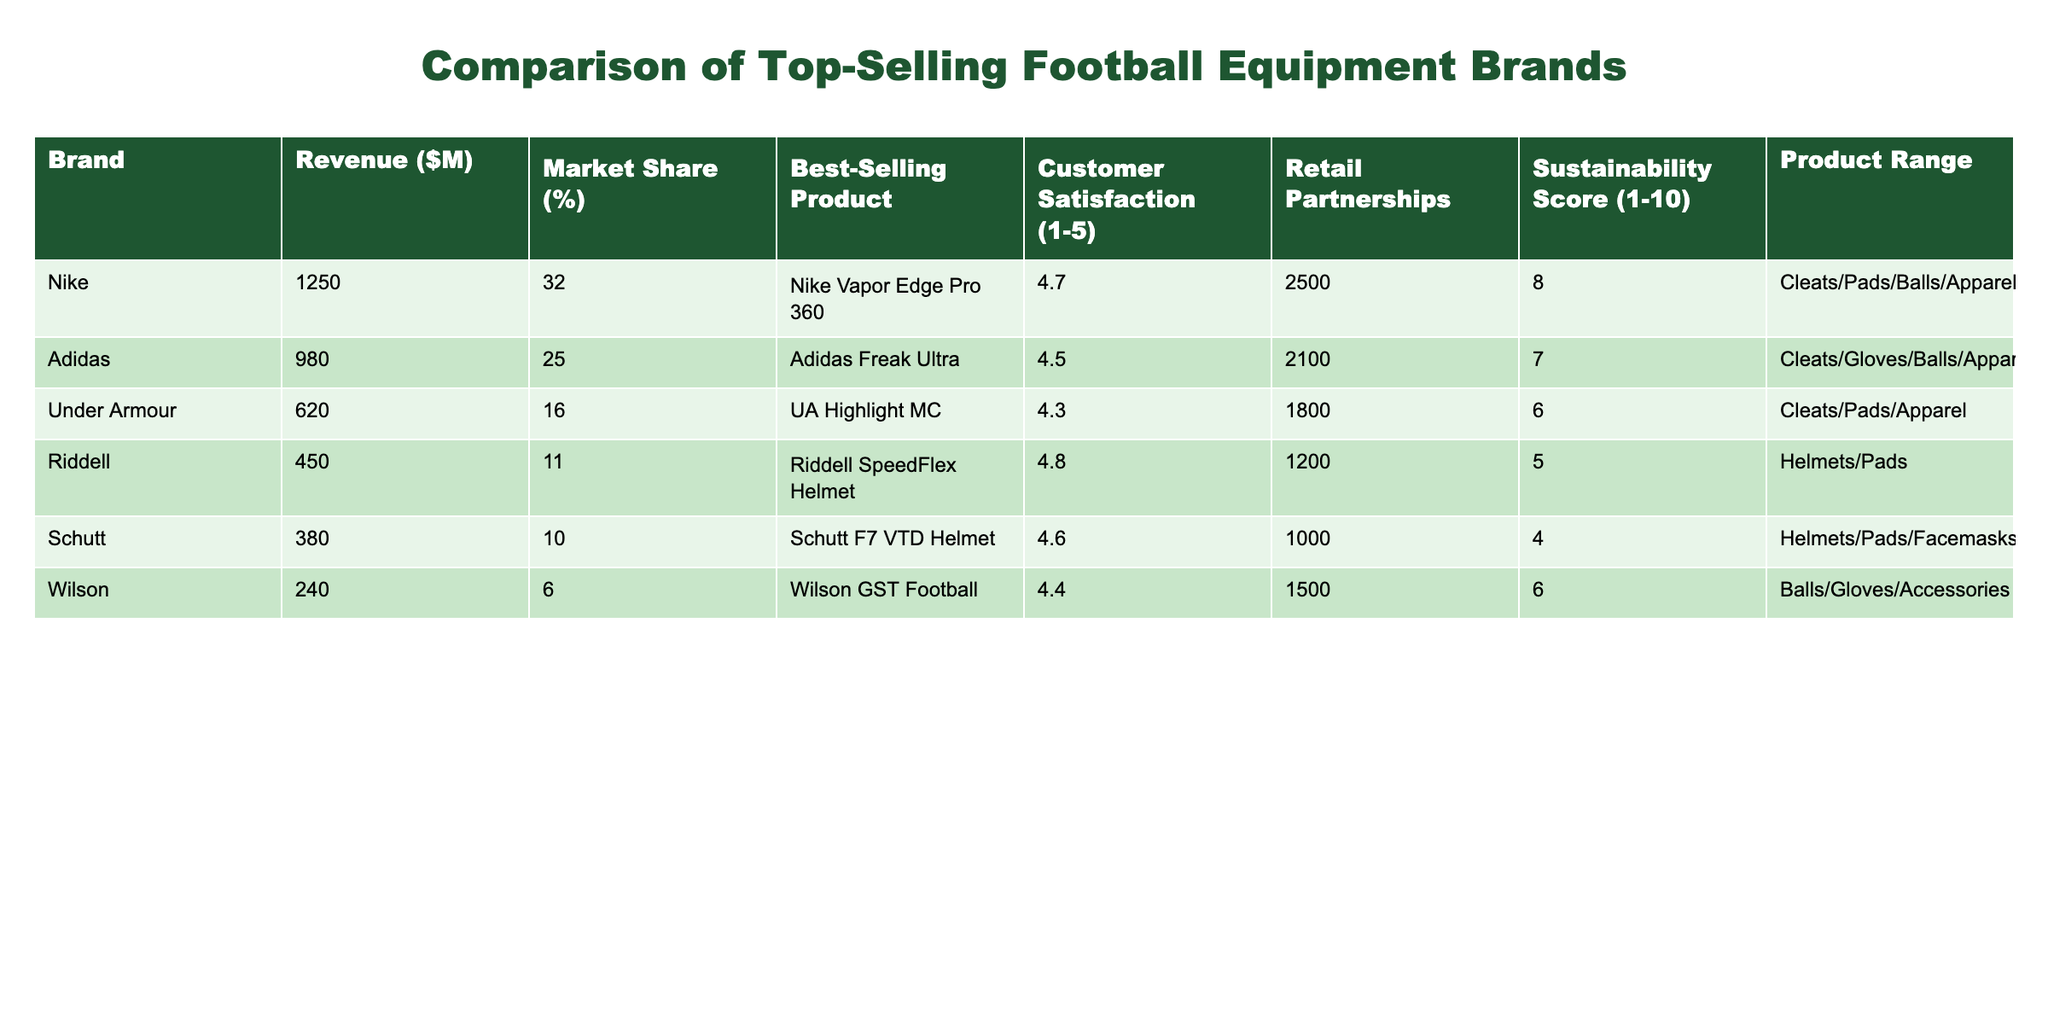What is the revenue generated by Nike? The revenue for Nike can be found directly in the table under the Revenue column. It states that Nike generated 1250 million dollars.
Answer: 1250 million dollars Which brand has the highest customer satisfaction rating? To determine this, we look at the Customer Satisfaction column and compare the ratings. The highest rating is 4.8, which corresponds to Riddell.
Answer: Riddell What is the market share of Adidas compared to Nike? Adidas has a market share of 25% while Nike has 32%. To find out the difference, we subtract Adidas's market share from Nike's: 32% - 25% = 7%.
Answer: 7% Is Wilson the only brand that sells accessories? Looking at the Product Range column, Wilson sells Balls, Gloves, and Accessories, while other brands focus on cleats, pads, or helmets. Therefore, Wilson is not the only brand with an accessory in its range.
Answer: No What brand has the best sustainability score and what is that score? We examine the Sustainability Score column and find that Nike has the highest score of 8.
Answer: Nike, score of 8 What is the average revenue of the brands listed? We calculate the sum of the revenues: 1250 + 980 + 620 + 450 + 380 + 240 = 3870 million dollars. There are 6 brands, so we divide the total revenue by 6: 3870 / 6 = 645 million dollars.
Answer: 645 million dollars Which brand has the second-highest market share, and what is it? The table shows that Nike has the highest market share at 32%, followed by Adidas at 25%. Therefore, Adidas is the second-highest market share brand.
Answer: Adidas, 25% Do all brands have a customer satisfaction rating of at least 4.0? By examining the Customer Satisfaction column, we see that all brands have ratings of 4.0 or higher, confirming that they indeed all meet this threshold.
Answer: Yes How many more retail partnerships does Nike have compared to Schutt? We find the number of retail partnerships for Nike, which is 2500, and for Schutt, it is 1000. To find the difference, we subtract 1000 from 2500: 2500 - 1000 = 1500.
Answer: 1500 